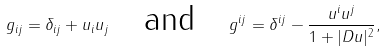Convert formula to latex. <formula><loc_0><loc_0><loc_500><loc_500>g _ { i j } = \delta _ { i j } + u _ { i } u _ { j } \quad \text {and} \quad g ^ { i j } = \delta ^ { i j } - \frac { u ^ { i } u ^ { j } } { 1 + | D u | ^ { 2 } } ,</formula> 